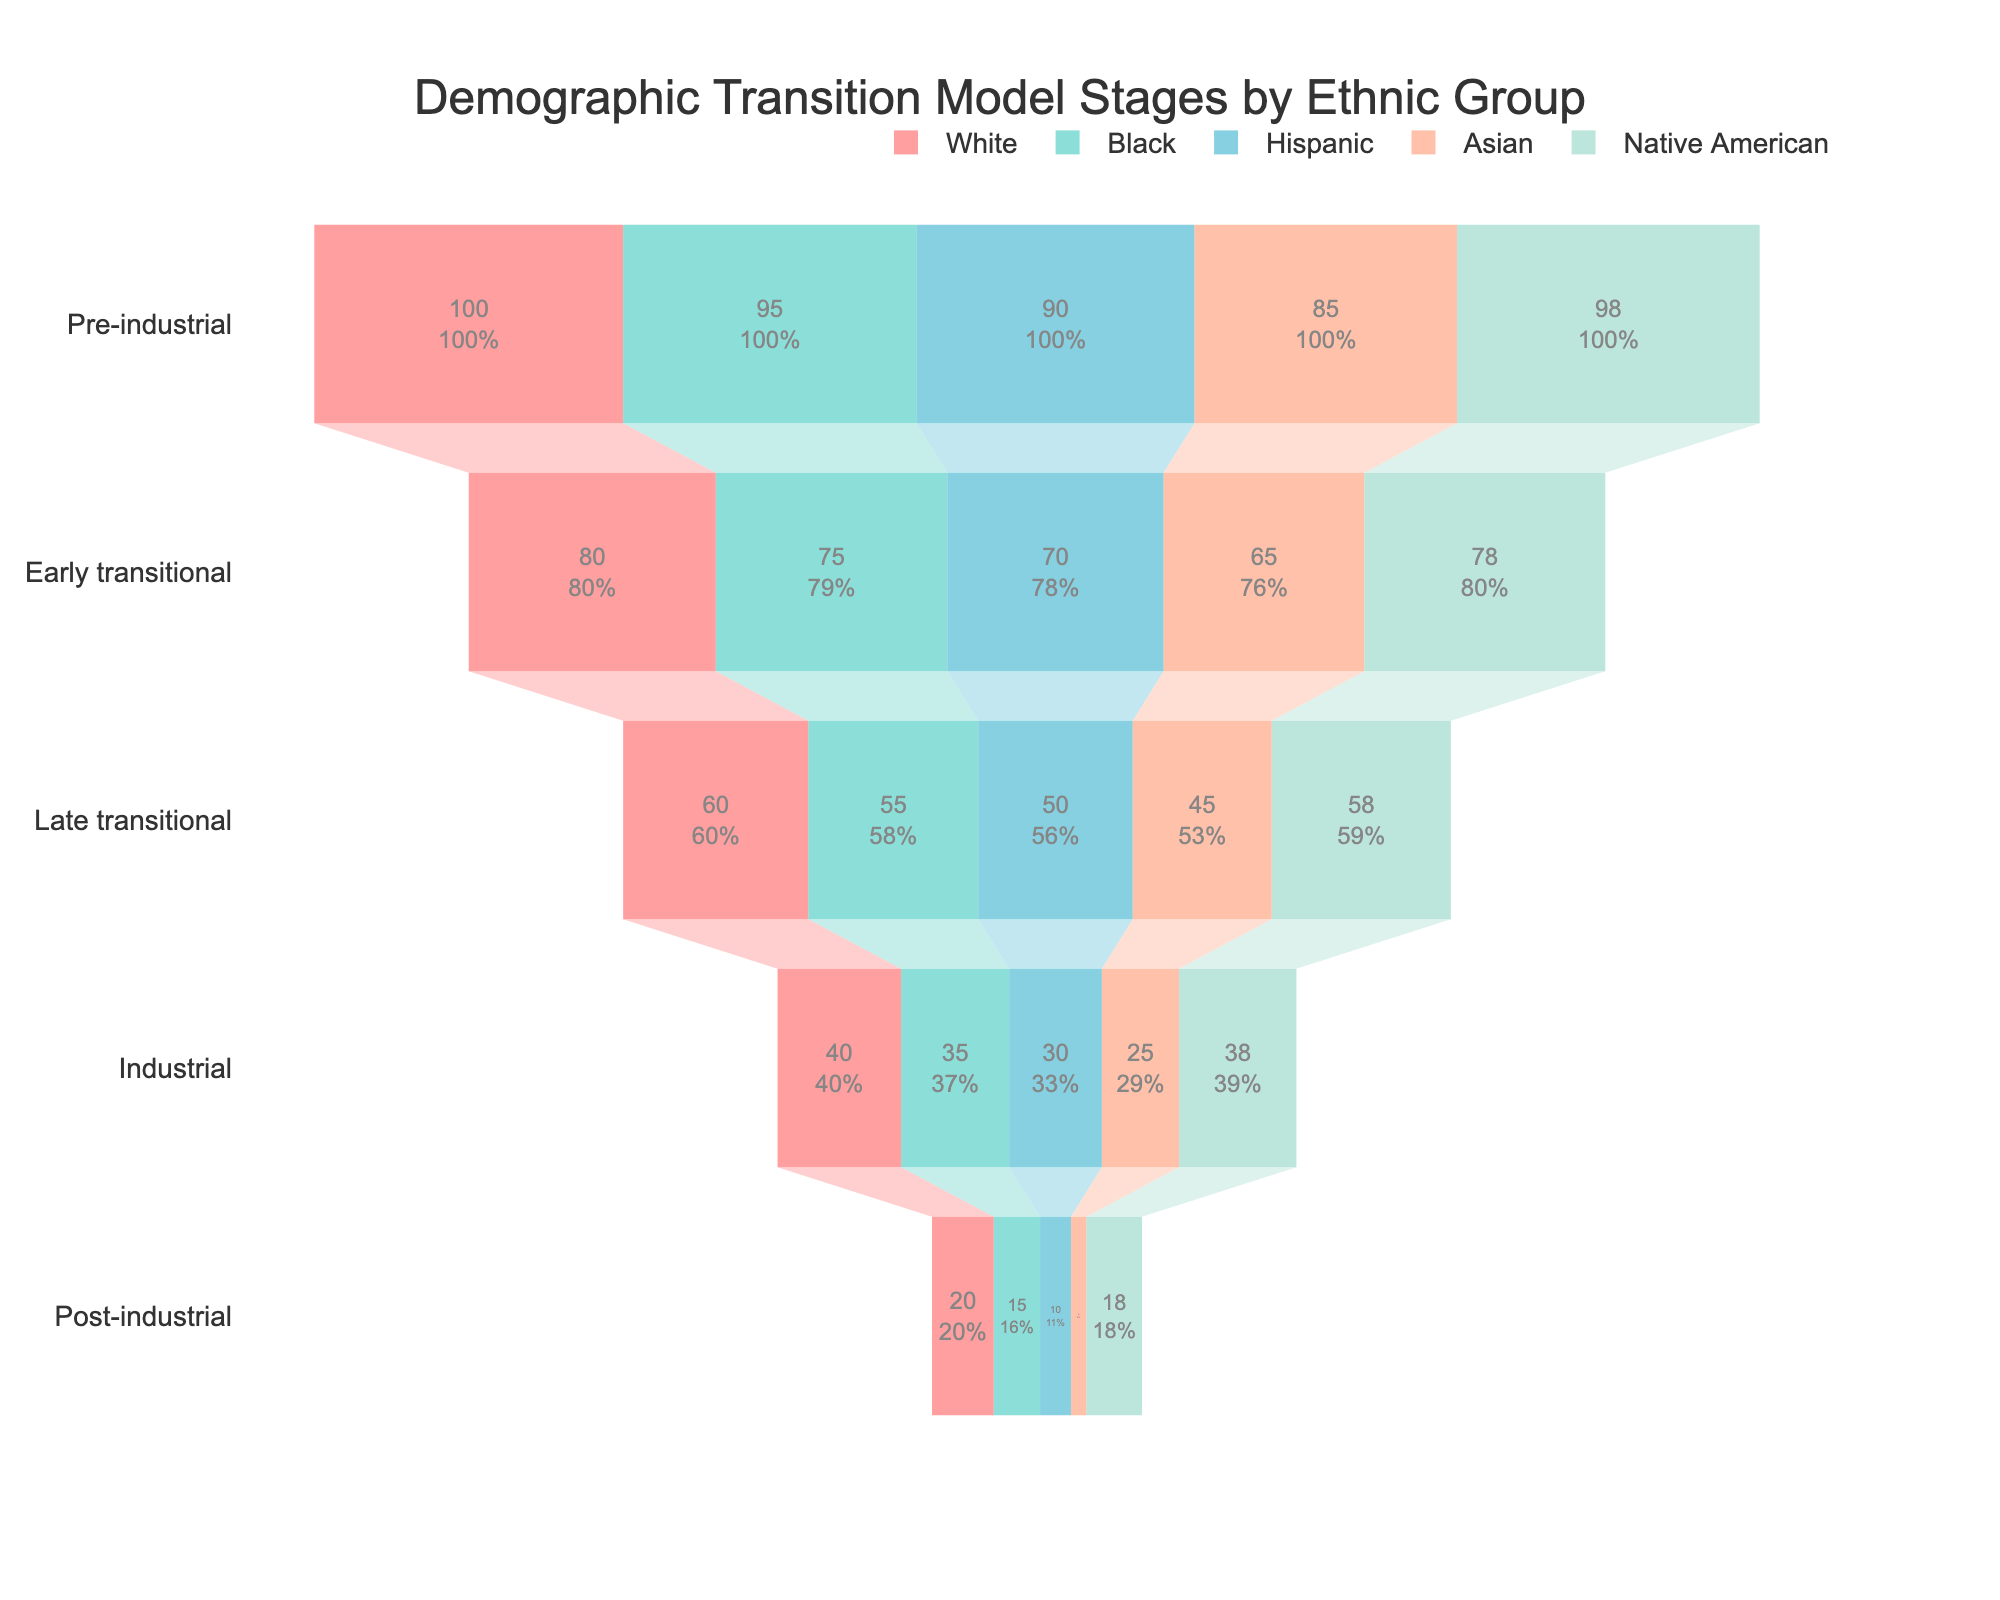What is the title of the figure? The title is specified at the top center of the figure and usually describes the main content or focus of the chart.
Answer: Demographic Transition Model Stages by Ethnic Group Which ethnic group has the highest value in the Pre-industrial stage? Look at the Pre-industrial stage values and identify which group has the highest.
Answer: White What is the difference in value between the Pre-industrial and Post-industrial stages for the Asian group? Subtract the Post-industrial value of the Asian group from the Pre-industrial value of the same group. 85 - 5 = 80
Answer: 80 Which ethnic group shows the steepest decline from the Pre-industrial to the Post-industrial stage? Calculate the difference between the Pre-industrial and Post-industrial stages for each group, and identify the largest difference.
Answer: Hispanic In the Late transitional stage, which two ethnic groups have the closest values? Compare the values of all groups in the Late transitional stage to find the two closest.
Answer: Asian and Native American What is the total value for the Black ethnic group across all stages? Sum the values of the Black group from each stage. 95 + 75 + 55 + 35 + 15 = 275
Answer: 275 Which ethnic group has the smallest value in the Industrial stage? Identify the group with the minimum value in the Industrial stage.
Answer: Asian How does the overall trend in the demographic transition stages compare between the White and Native American groups? Analyze the changes in values of both groups across the stages and compare their trends over time. Both groups show a consistent decrease, but White values are consistently higher than Native American values at each stage.
Answer: Consistent decrease, White values higher What percentage of the Post-industrial stage value of the White group is the corresponding value for the Hispanic group? Divide the Post-industrial value of the Hispanic group by the Post-industrial value of the White group and multiply by 100. (10 / 20) * 100 = 50%
Answer: 50% Which ethnic group maintains the most stable transition across stages, as indicated by the smallest change in values between consecutive stages? Calculate the differences between consecutive stages for each group and identify the group with the smallest cumulative change.
Answer: Native American 